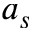Convert formula to latex. <formula><loc_0><loc_0><loc_500><loc_500>a _ { s }</formula> 